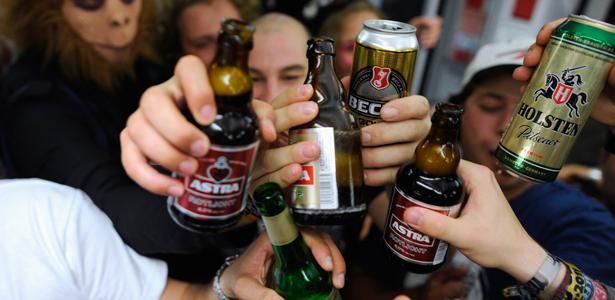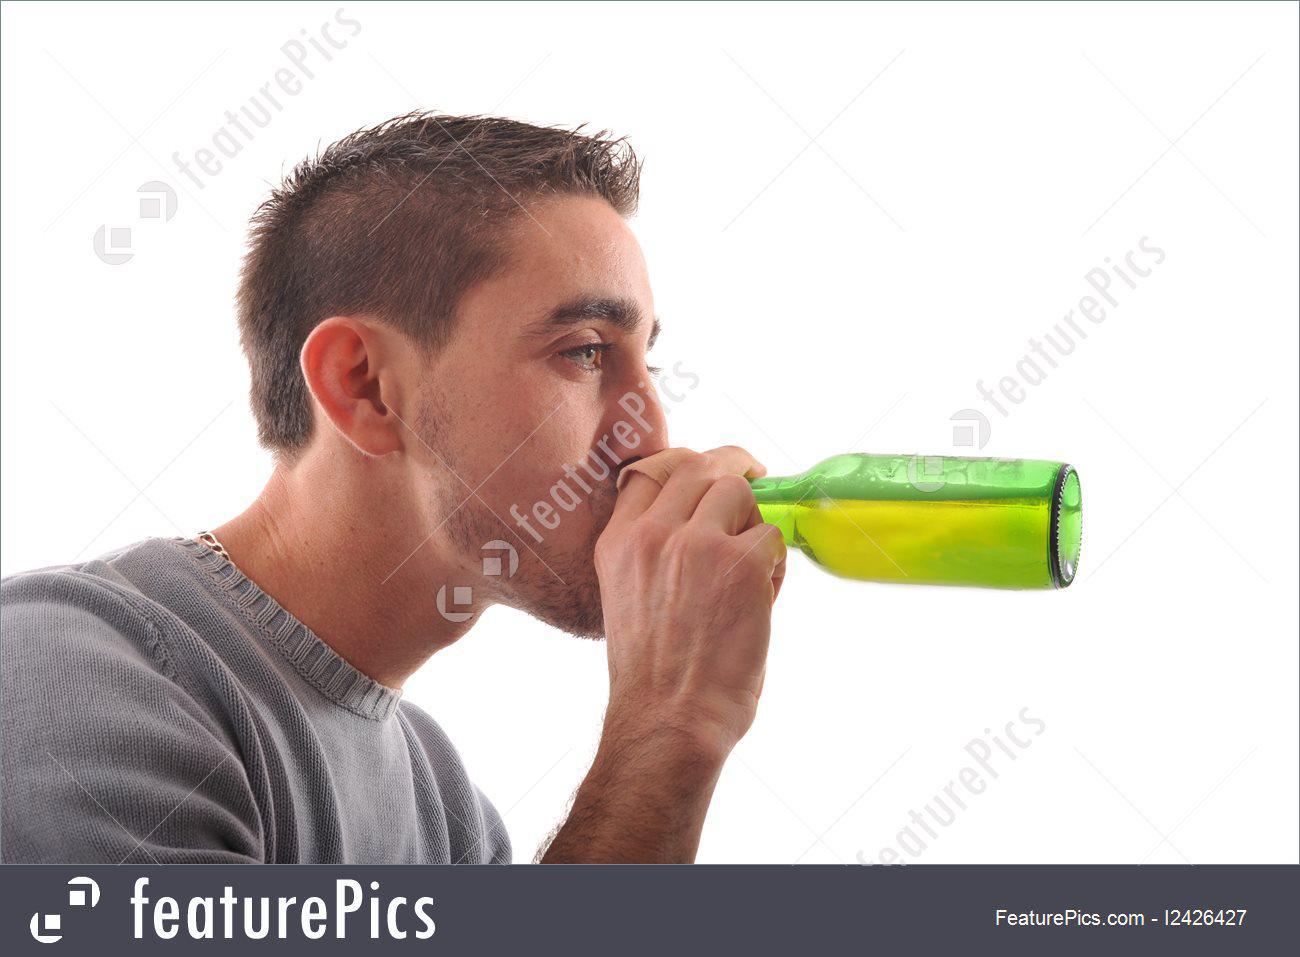The first image is the image on the left, the second image is the image on the right. Evaluate the accuracy of this statement regarding the images: "There are a total of nine people.". Is it true? Answer yes or no. No. The first image is the image on the left, the second image is the image on the right. Assess this claim about the two images: "A man is holding a bottle to his mouth.". Correct or not? Answer yes or no. Yes. 